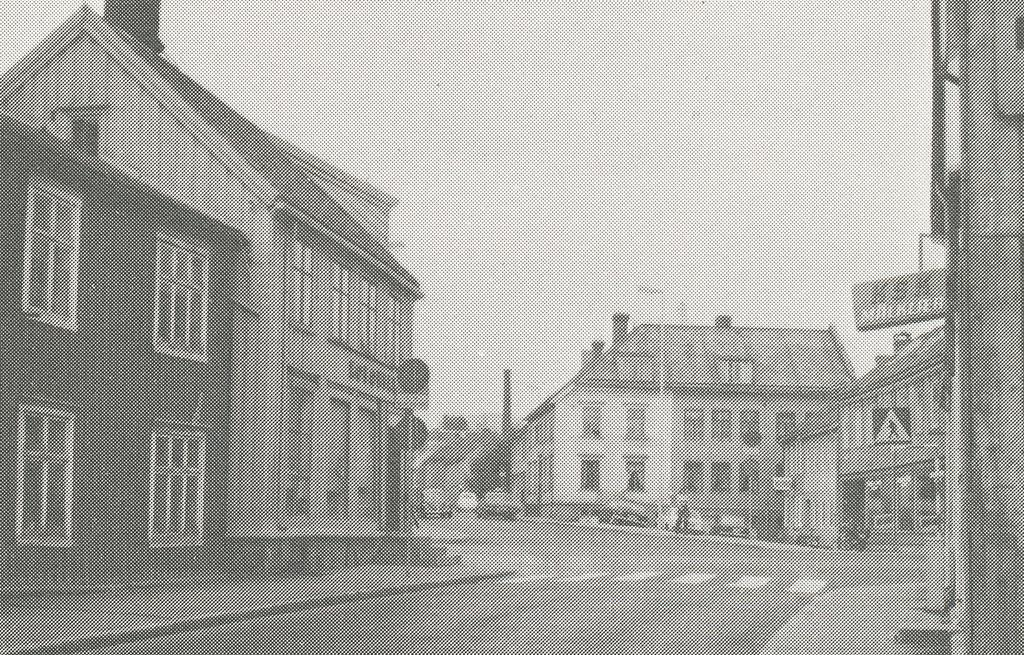<image>
Describe the image concisely. The large letters on the sign above the building show KSK. 